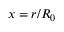<formula> <loc_0><loc_0><loc_500><loc_500>x = r / R _ { 0 }</formula> 